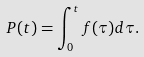<formula> <loc_0><loc_0><loc_500><loc_500>P ( t ) = \int _ { 0 } ^ { t } f ( \tau ) d \tau .</formula> 